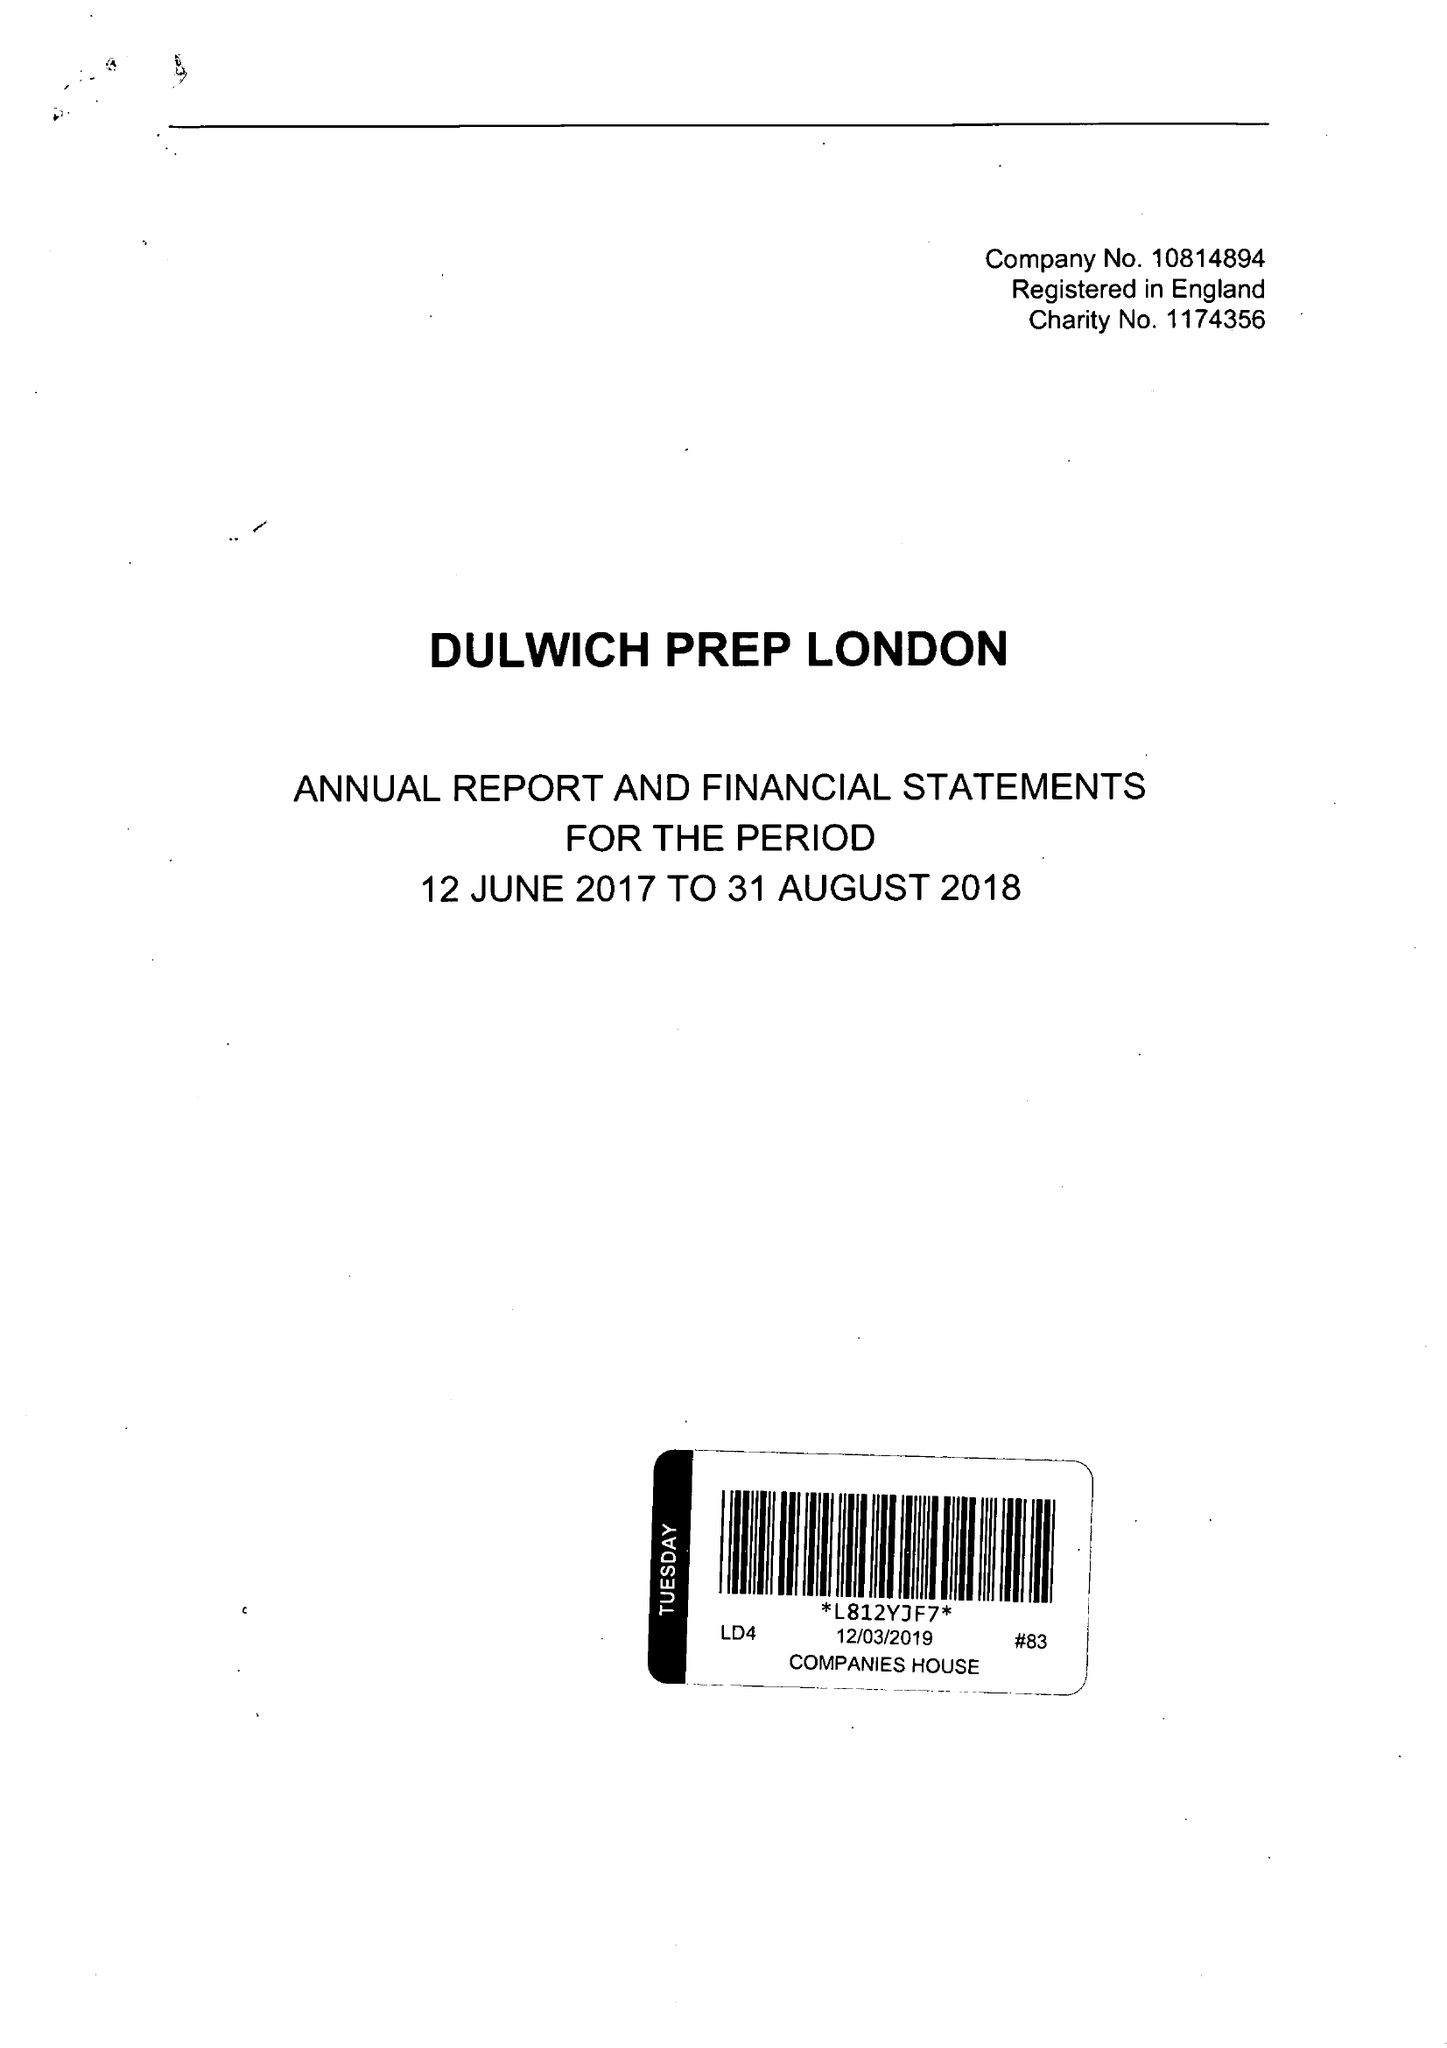What is the value for the address__street_line?
Answer the question using a single word or phrase. 38-42 ALLEYN PARK 